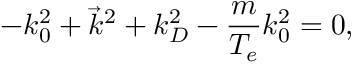Convert formula to latex. <formula><loc_0><loc_0><loc_500><loc_500>- k _ { 0 } ^ { 2 } + { \vec { k } } ^ { 2 } + k _ { D } ^ { 2 } - { \frac { m } { T _ { e } } } k _ { 0 } ^ { 2 } = 0 ,</formula> 